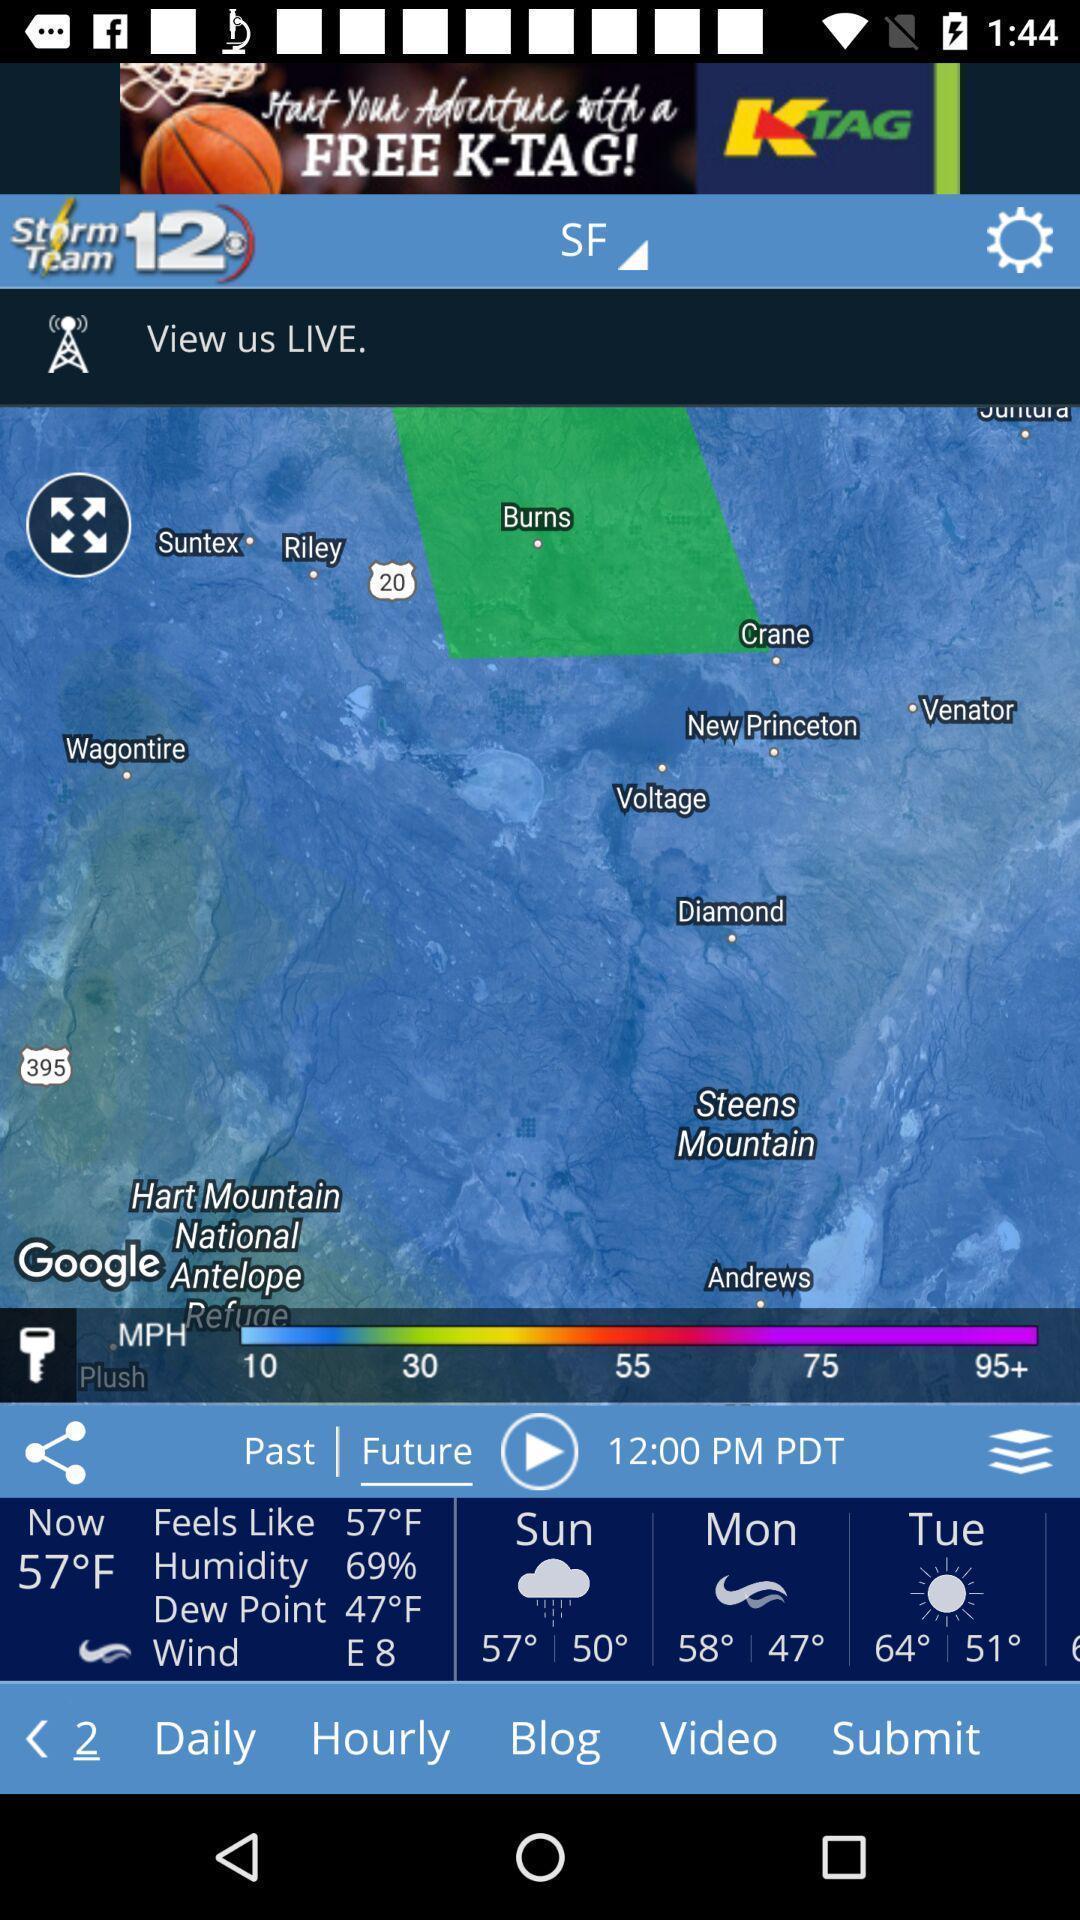Give me a summary of this screen capture. Weather application displaying weather info and other features. 